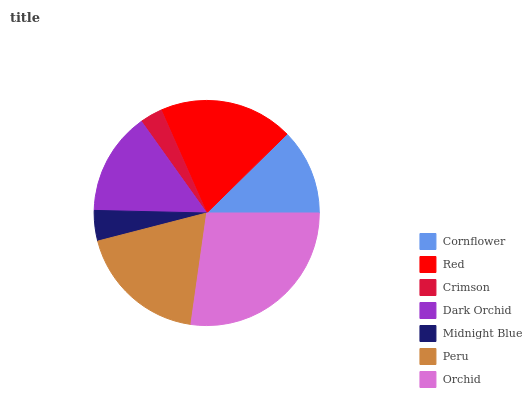Is Crimson the minimum?
Answer yes or no. Yes. Is Orchid the maximum?
Answer yes or no. Yes. Is Red the minimum?
Answer yes or no. No. Is Red the maximum?
Answer yes or no. No. Is Red greater than Cornflower?
Answer yes or no. Yes. Is Cornflower less than Red?
Answer yes or no. Yes. Is Cornflower greater than Red?
Answer yes or no. No. Is Red less than Cornflower?
Answer yes or no. No. Is Dark Orchid the high median?
Answer yes or no. Yes. Is Dark Orchid the low median?
Answer yes or no. Yes. Is Peru the high median?
Answer yes or no. No. Is Midnight Blue the low median?
Answer yes or no. No. 